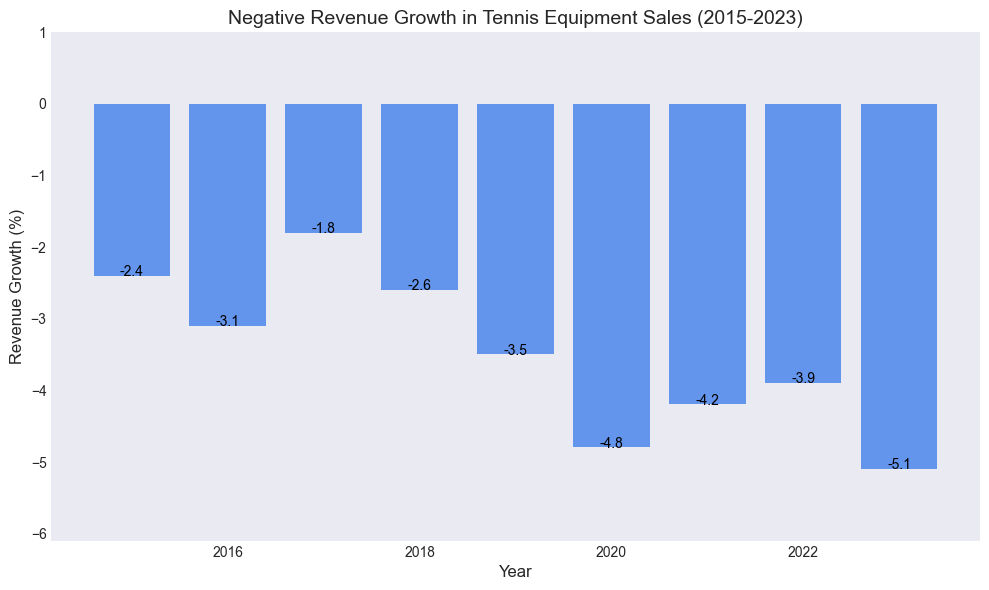Which year showed the most significant negative revenue growth? In the bar chart, identify which bar extends the furthest downwards, indicating the most negative value. The bar that reaches the furthest down represents the most significant negative revenue growth.
Answer: 2023 How much did the revenue growth decline from 2020 to 2023? Find the revenue growth percentages for 2020 and 2023. Calculate the difference between these two values: -4.8 (2020) to -5.1 (2023). Use subtraction: -5.1 - (-4.8) = -0.3. This indicates an additional decline of 0.3%.
Answer: 0.3% What was the total revenue growth decline between 2015-2019? Add the revenue growth percentages from 2015 to 2019: -2.4 + (-3.1) + (-1.8) + (-2.6) + (-3.5). Calculate the sum of these values: -2.4 - 3.1 - 1.8 - 2.6 - 3.5 = -13.4%.
Answer: -13.4% In which years was the negative revenue growth less than -2.0%? Identify the bars in the chart that do not extend below -2.0%. These will be the years where the negative revenue growth is less severe than -2.0%. The data shows 2016, 2019, 2020, 2021, 2022, and 2023.
Answer: 2017 How much did the revenue growth decline from 2017 to 2018? Locate the bars for 2017 and 2018. Calculate the difference between these two values: -2.6 (2018) - (-1.8) (2017). Use subtraction: -2.6 - (-1.8) = -2.6 + 1.8 = -0.8.
Answer: 0.8% Which year had the least negative revenue growth? Identify the year in the chart with the bar that extends the least downward, indicating the smallest negative value. This is the year 2017, with -1.8%.
Answer: 2017 What is the average negative revenue growth from 2015 to 2023? Sum up all the revenue growth percentages from 2015 to 2023 and divide by the number of years (9): (-2.4 - 3.1 - 1.8 - 2.6 - 3.5 - 4.8 - 4.2 - 3.9 - 5.1) / 9. Calculate: -31.4 / 9 = -3.49%.
Answer: -3.49% 